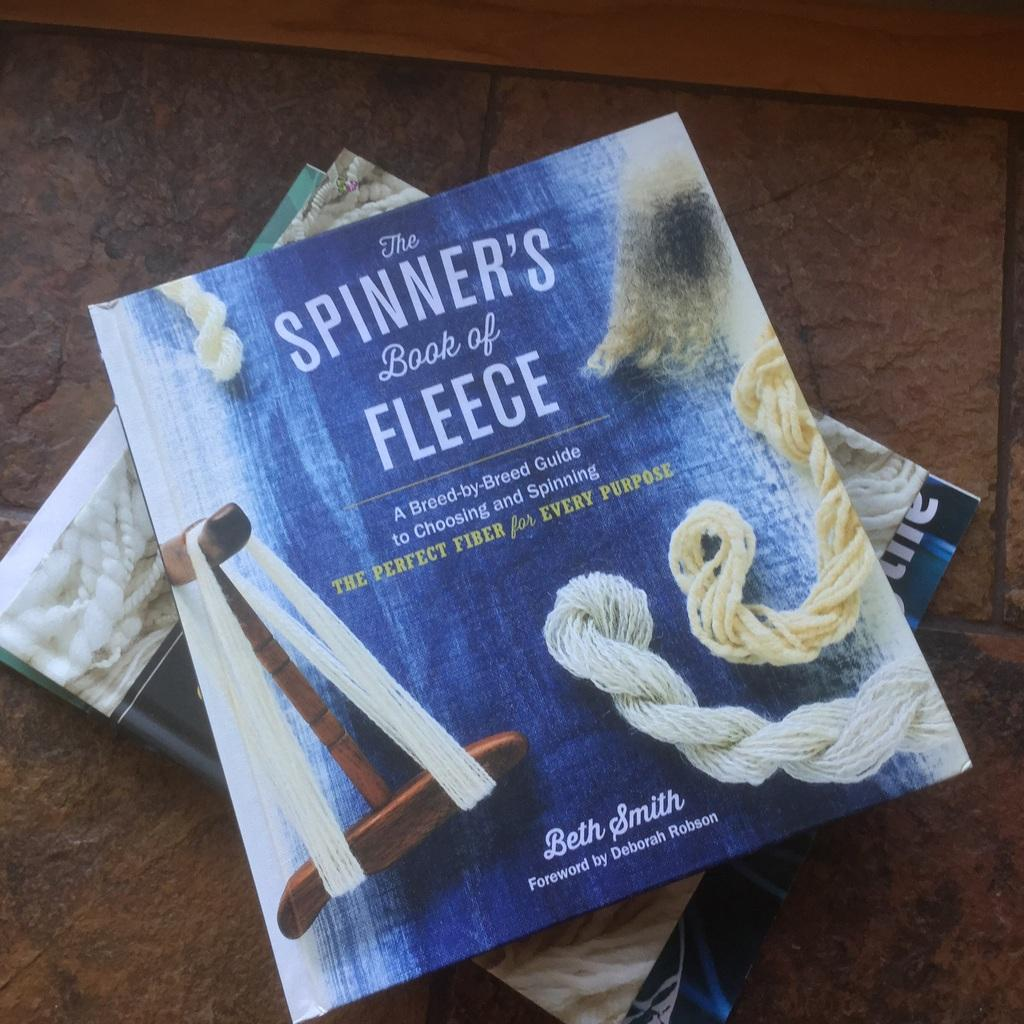<image>
Relay a brief, clear account of the picture shown. Several books pilled up on tiles with The Spinner's Book of Fleece on the top. 